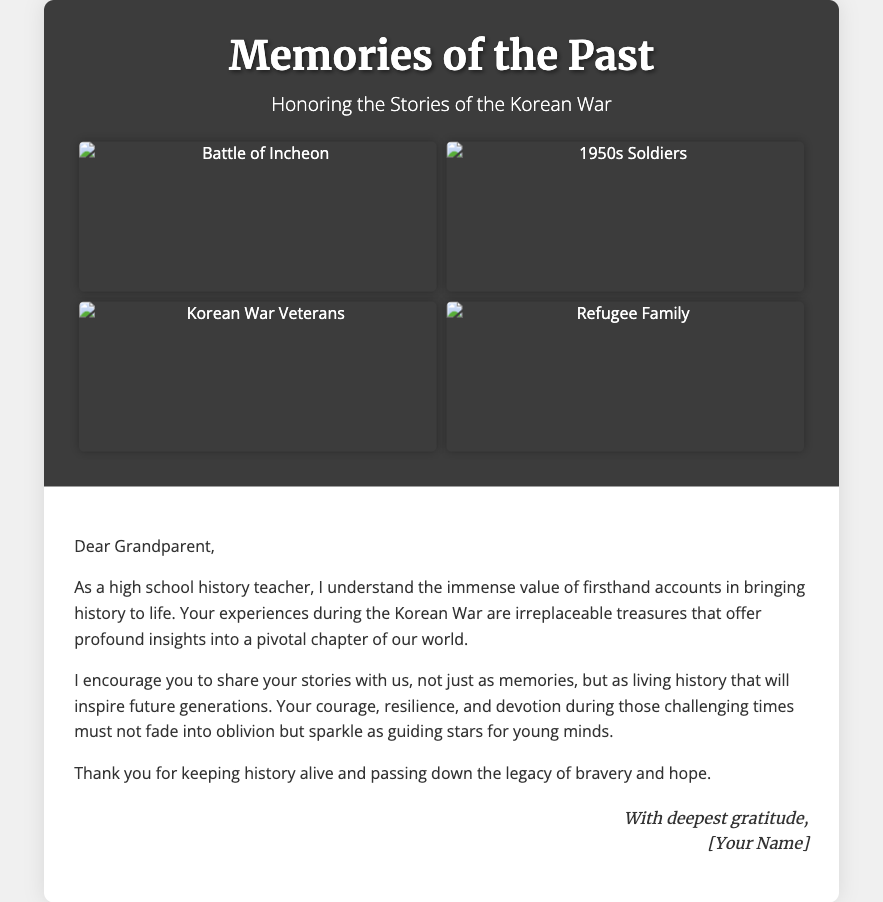What is the title of the card? The title of the card is prominently displayed at the top of the document.
Answer: Memories of the Past What is the subtitle? The subtitle is located directly beneath the title and provides context for the card’s theme.
Answer: Honoring the Stories of the Korean War How many photos are included in the collage? The collage features four distinct photos related to the Korean War.
Answer: Four What is the main color of the card cover? The primary color of the card's cover is indicated in the visual design.
Answer: Dark gray What message does the card encourage from the grandparent? The card's message conveys a specific request to the grandparent regarding their experiences.
Answer: Share stories What type of stories does the card emphasize? The emphasis is placed on the nature of the stories that should be shared.
Answer: Firsthand accounts Who is the sender of the card? The signing off at the end of the card reveals the identity of the sender.
Answer: [Your Name] What emotion does the card primarily convey? Analyzing the language used throughout the card reveals the predominant feeling it aims to express.
Answer: Gratitude How does the card describe the experiences of the grandparent? The card reflects on the significance of the grandparent’s experiences in historical context.
Answer: Irreplaceable treasures 